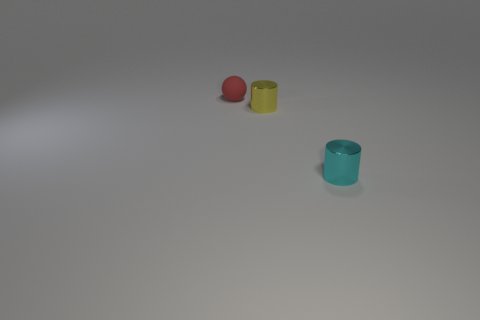Add 2 matte things. How many objects exist? 5 Subtract all balls. How many objects are left? 2 Subtract all small yellow cylinders. Subtract all rubber things. How many objects are left? 1 Add 3 metal cylinders. How many metal cylinders are left? 5 Add 3 tiny matte things. How many tiny matte things exist? 4 Subtract 0 blue cubes. How many objects are left? 3 